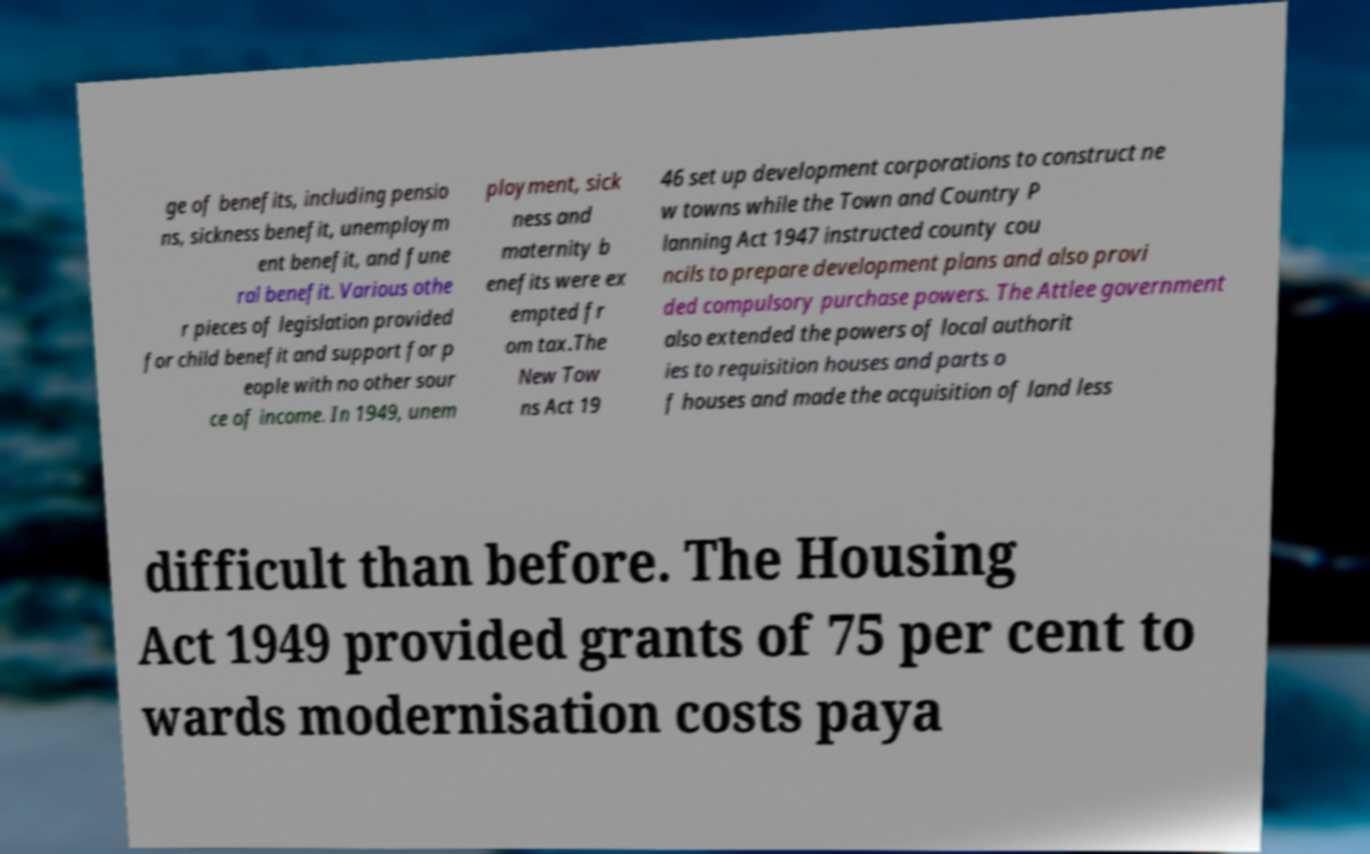What messages or text are displayed in this image? I need them in a readable, typed format. ge of benefits, including pensio ns, sickness benefit, unemploym ent benefit, and fune ral benefit. Various othe r pieces of legislation provided for child benefit and support for p eople with no other sour ce of income. In 1949, unem ployment, sick ness and maternity b enefits were ex empted fr om tax.The New Tow ns Act 19 46 set up development corporations to construct ne w towns while the Town and Country P lanning Act 1947 instructed county cou ncils to prepare development plans and also provi ded compulsory purchase powers. The Attlee government also extended the powers of local authorit ies to requisition houses and parts o f houses and made the acquisition of land less difficult than before. The Housing Act 1949 provided grants of 75 per cent to wards modernisation costs paya 